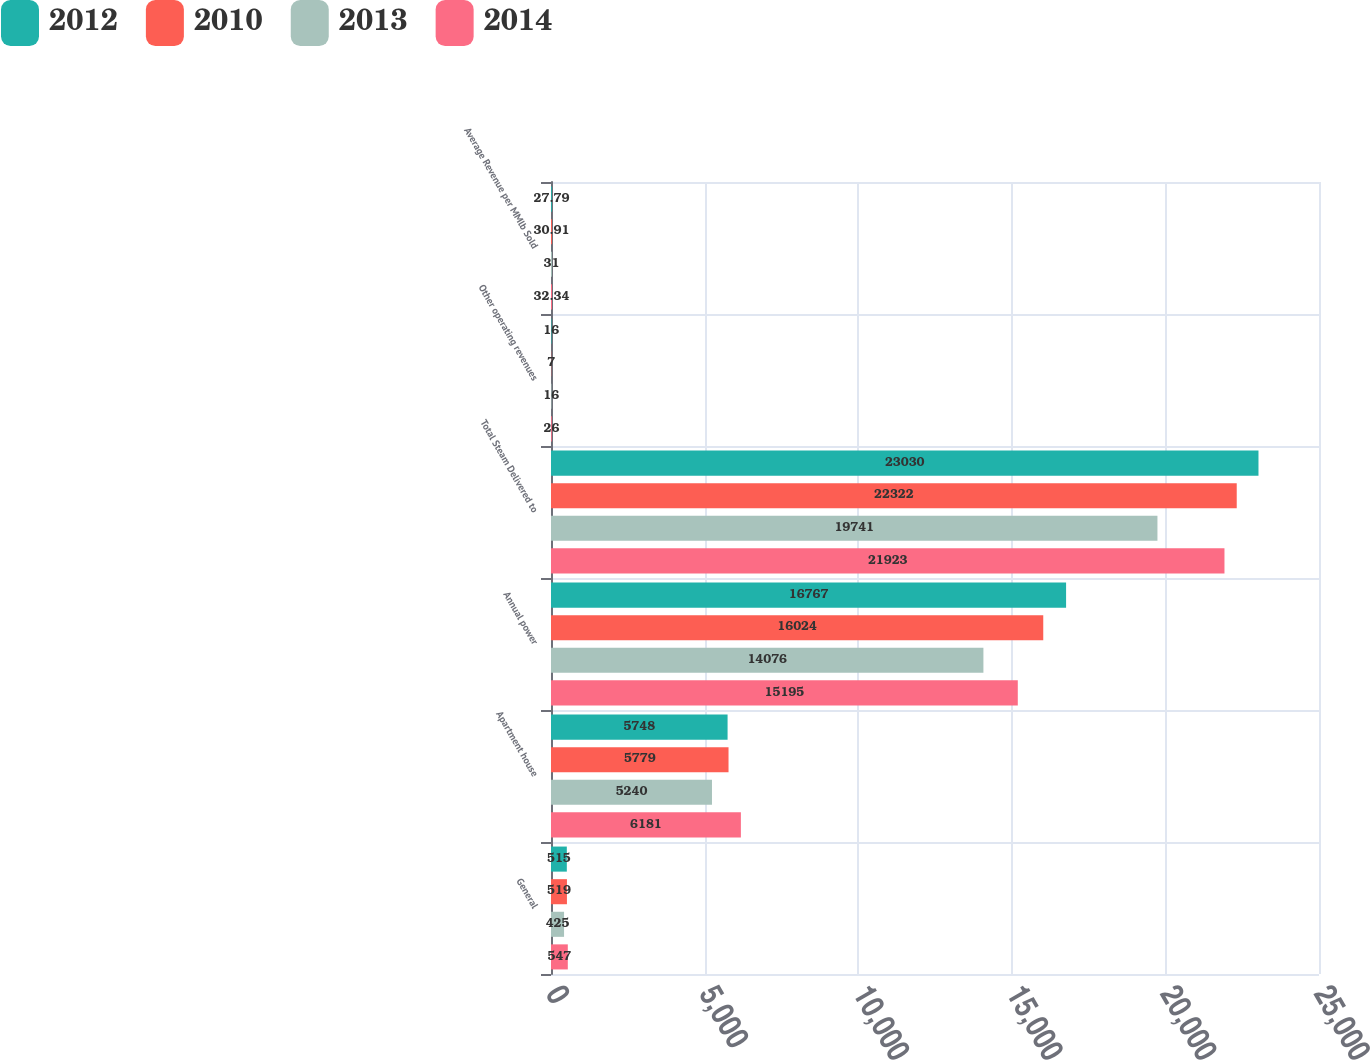<chart> <loc_0><loc_0><loc_500><loc_500><stacked_bar_chart><ecel><fcel>General<fcel>Apartment house<fcel>Annual power<fcel>Total Steam Delivered to<fcel>Other operating revenues<fcel>Average Revenue per MMlb Sold<nl><fcel>2012<fcel>515<fcel>5748<fcel>16767<fcel>23030<fcel>16<fcel>27.79<nl><fcel>2010<fcel>519<fcel>5779<fcel>16024<fcel>22322<fcel>7<fcel>30.91<nl><fcel>2013<fcel>425<fcel>5240<fcel>14076<fcel>19741<fcel>16<fcel>31<nl><fcel>2014<fcel>547<fcel>6181<fcel>15195<fcel>21923<fcel>26<fcel>32.34<nl></chart> 